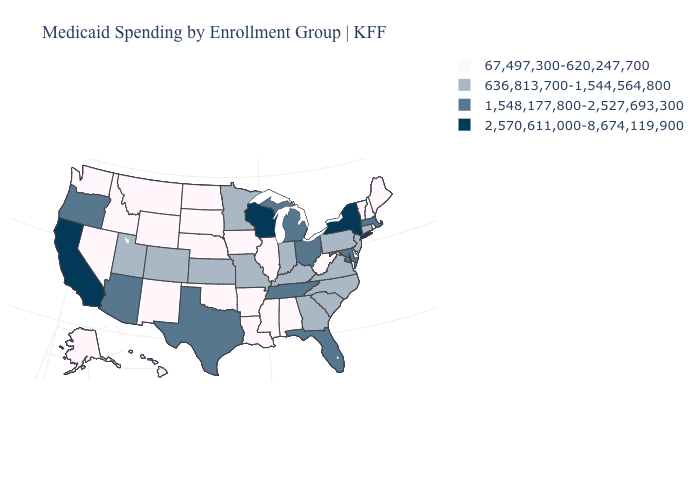Name the states that have a value in the range 636,813,700-1,544,564,800?
Concise answer only. Colorado, Connecticut, Georgia, Indiana, Kansas, Kentucky, Minnesota, Missouri, New Jersey, North Carolina, Pennsylvania, South Carolina, Utah, Virginia. How many symbols are there in the legend?
Short answer required. 4. Does Virginia have the lowest value in the USA?
Keep it brief. No. Among the states that border North Carolina , which have the lowest value?
Write a very short answer. Georgia, South Carolina, Virginia. Does Utah have a lower value than South Carolina?
Give a very brief answer. No. What is the lowest value in states that border North Carolina?
Keep it brief. 636,813,700-1,544,564,800. What is the value of West Virginia?
Short answer required. 67,497,300-620,247,700. Name the states that have a value in the range 1,548,177,800-2,527,693,300?
Answer briefly. Arizona, Florida, Maryland, Massachusetts, Michigan, Ohio, Oregon, Tennessee, Texas. What is the lowest value in states that border Nevada?
Write a very short answer. 67,497,300-620,247,700. Which states have the lowest value in the Northeast?
Answer briefly. Maine, New Hampshire, Rhode Island, Vermont. What is the value of Utah?
Concise answer only. 636,813,700-1,544,564,800. What is the value of Nevada?
Concise answer only. 67,497,300-620,247,700. How many symbols are there in the legend?
Keep it brief. 4. Name the states that have a value in the range 67,497,300-620,247,700?
Keep it brief. Alabama, Alaska, Arkansas, Delaware, Hawaii, Idaho, Illinois, Iowa, Louisiana, Maine, Mississippi, Montana, Nebraska, Nevada, New Hampshire, New Mexico, North Dakota, Oklahoma, Rhode Island, South Dakota, Vermont, Washington, West Virginia, Wyoming. 